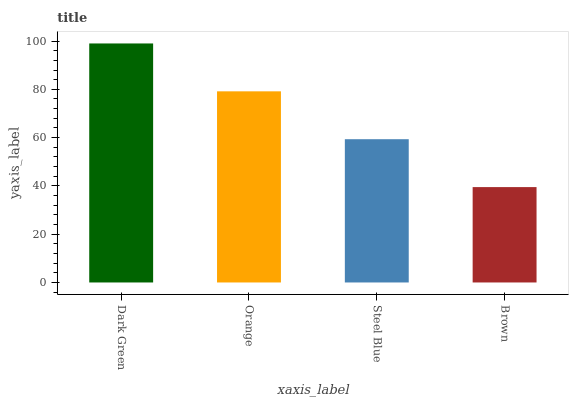Is Orange the minimum?
Answer yes or no. No. Is Orange the maximum?
Answer yes or no. No. Is Dark Green greater than Orange?
Answer yes or no. Yes. Is Orange less than Dark Green?
Answer yes or no. Yes. Is Orange greater than Dark Green?
Answer yes or no. No. Is Dark Green less than Orange?
Answer yes or no. No. Is Orange the high median?
Answer yes or no. Yes. Is Steel Blue the low median?
Answer yes or no. Yes. Is Steel Blue the high median?
Answer yes or no. No. Is Orange the low median?
Answer yes or no. No. 